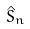<formula> <loc_0><loc_0><loc_500><loc_500>\hat { S } _ { n }</formula> 